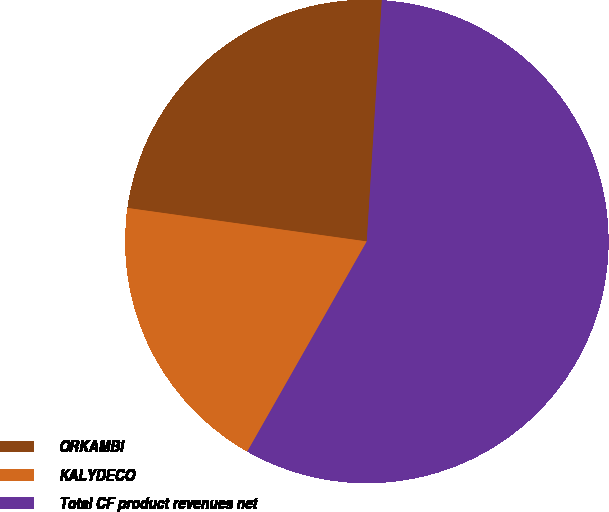Convert chart. <chart><loc_0><loc_0><loc_500><loc_500><pie_chart><fcel>ORKAMBI<fcel>KALYDECO<fcel>Total CF product revenues net<nl><fcel>23.78%<fcel>18.98%<fcel>57.24%<nl></chart> 